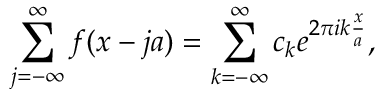<formula> <loc_0><loc_0><loc_500><loc_500>\sum _ { j = - \infty } ^ { \infty } f ( x - j a ) = \sum _ { k = - \infty } ^ { \infty } c _ { k } e ^ { 2 \pi i k \frac { x } { a } } ,</formula> 